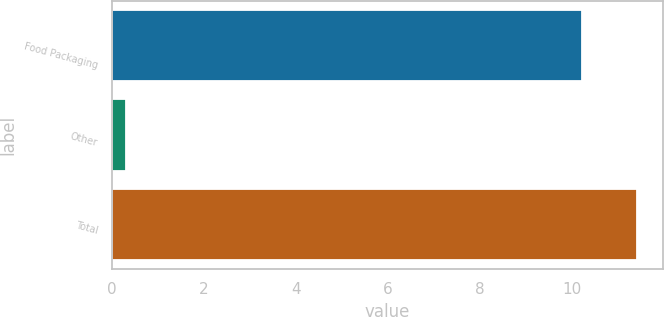Convert chart to OTSL. <chart><loc_0><loc_0><loc_500><loc_500><bar_chart><fcel>Food Packaging<fcel>Other<fcel>Total<nl><fcel>10.2<fcel>0.3<fcel>11.4<nl></chart> 